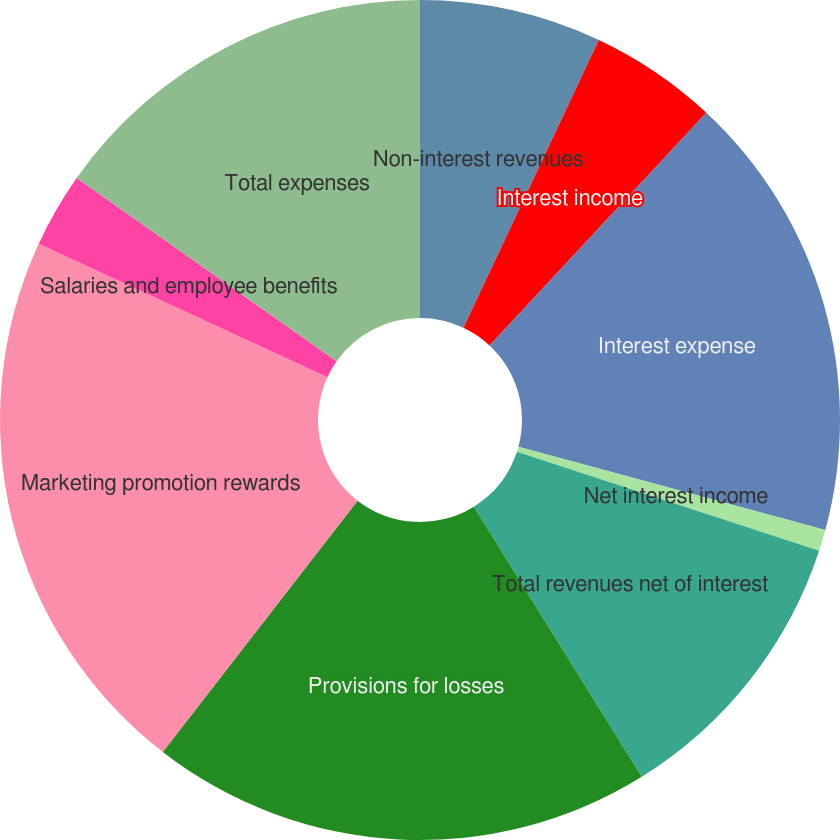<chart> <loc_0><loc_0><loc_500><loc_500><pie_chart><fcel>Non-interest revenues<fcel>Interest income<fcel>Interest expense<fcel>Net interest income<fcel>Total revenues net of interest<fcel>Provisions for losses<fcel>Marketing promotion rewards<fcel>Salaries and employee benefits<fcel>Total expenses<nl><fcel>7.0%<fcel>4.94%<fcel>17.28%<fcel>0.82%<fcel>11.11%<fcel>19.34%<fcel>21.4%<fcel>2.88%<fcel>15.23%<nl></chart> 